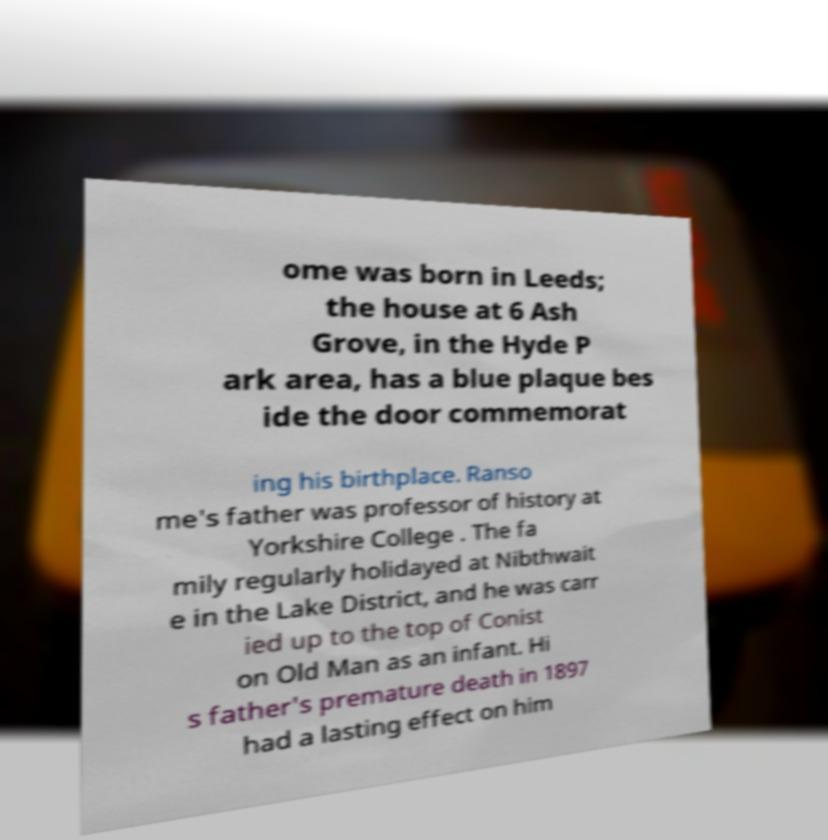For documentation purposes, I need the text within this image transcribed. Could you provide that? ome was born in Leeds; the house at 6 Ash Grove, in the Hyde P ark area, has a blue plaque bes ide the door commemorat ing his birthplace. Ranso me's father was professor of history at Yorkshire College . The fa mily regularly holidayed at Nibthwait e in the Lake District, and he was carr ied up to the top of Conist on Old Man as an infant. Hi s father's premature death in 1897 had a lasting effect on him 